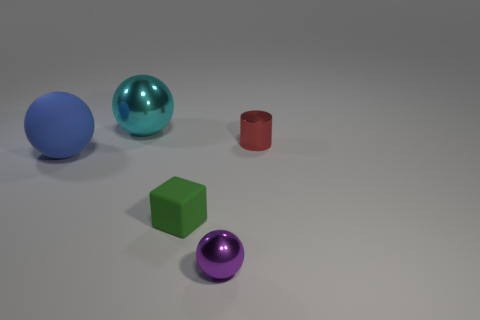How many tiny green objects are right of the sphere that is in front of the small green rubber object?
Provide a succinct answer. 0. What is the material of the sphere that is both in front of the cylinder and behind the small green block?
Offer a terse response. Rubber. There is a metal thing behind the small red shiny cylinder; is it the same shape as the large blue thing?
Provide a succinct answer. Yes. Are there fewer blue balls than brown shiny balls?
Give a very brief answer. No. Is the number of cylinders greater than the number of small green metal things?
Your answer should be very brief. Yes. What size is the other metal thing that is the same shape as the cyan metallic thing?
Offer a very short reply. Small. Do the small ball and the small thing that is behind the tiny block have the same material?
Your answer should be very brief. Yes. What number of objects are small blue balls or tiny things?
Make the answer very short. 3. Is the size of the metallic ball that is behind the purple metal object the same as the matte object that is to the right of the large cyan metal ball?
Provide a succinct answer. No. How many cubes are blue rubber objects or small shiny objects?
Keep it short and to the point. 0. 